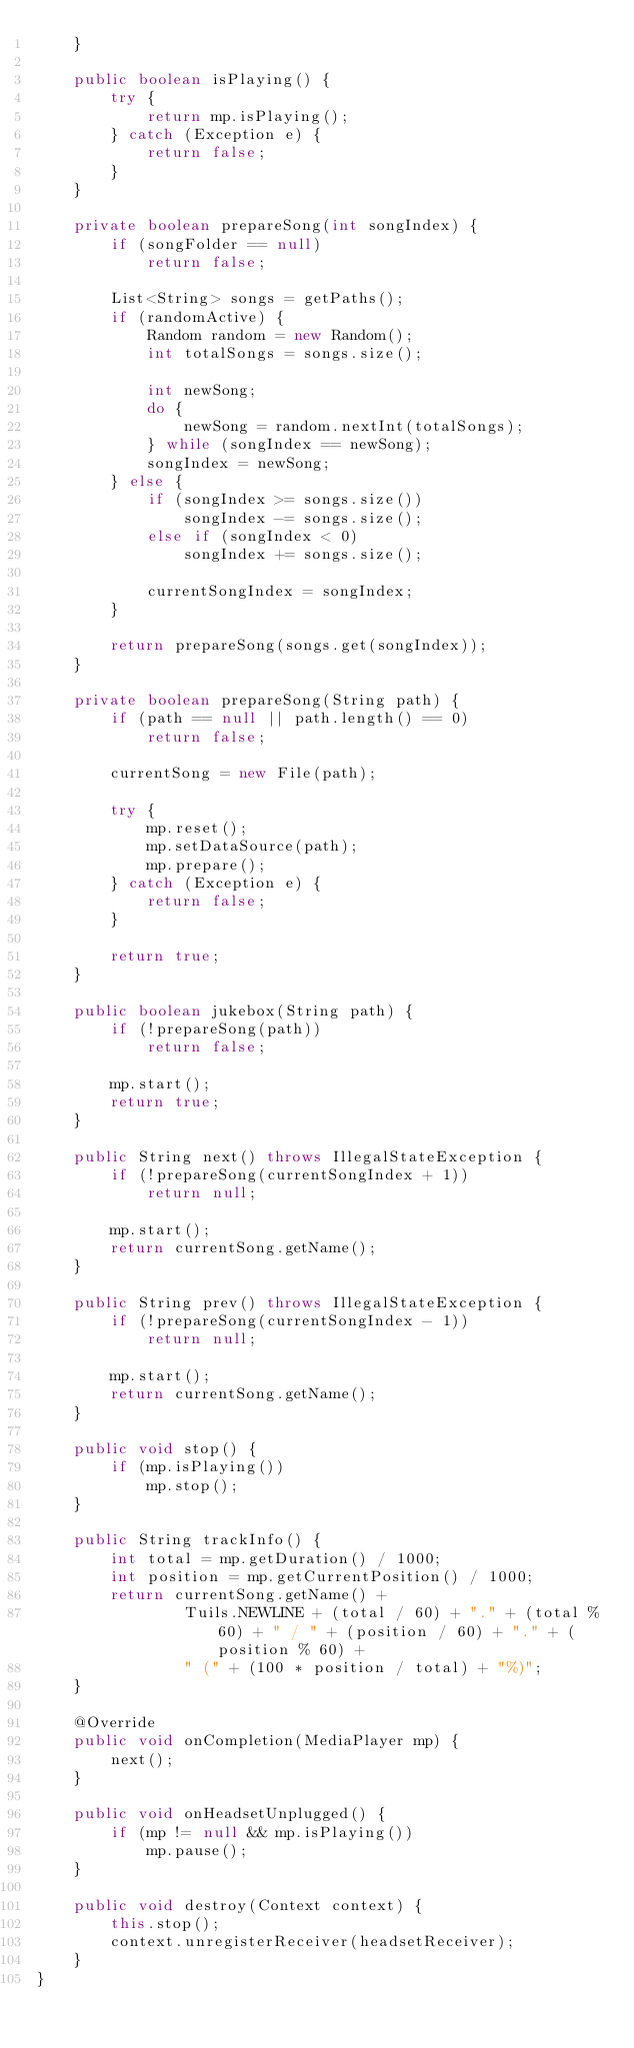<code> <loc_0><loc_0><loc_500><loc_500><_Java_>    }

    public boolean isPlaying() {
        try {
            return mp.isPlaying();
        } catch (Exception e) {
            return false;
        }
    }

    private boolean prepareSong(int songIndex) {
        if (songFolder == null)
            return false;

        List<String> songs = getPaths();
        if (randomActive) {
            Random random = new Random();
            int totalSongs = songs.size();

            int newSong;
            do {
                newSong = random.nextInt(totalSongs);
            } while (songIndex == newSong);
            songIndex = newSong;
        } else {
            if (songIndex >= songs.size())
                songIndex -= songs.size();
            else if (songIndex < 0)
                songIndex += songs.size();

            currentSongIndex = songIndex;
        }

        return prepareSong(songs.get(songIndex));
    }

    private boolean prepareSong(String path) {
        if (path == null || path.length() == 0)
            return false;

        currentSong = new File(path);

        try {
            mp.reset();
            mp.setDataSource(path);
            mp.prepare();
        } catch (Exception e) {
            return false;
        }

        return true;
    }

    public boolean jukebox(String path) {
        if (!prepareSong(path))
            return false;

        mp.start();
        return true;
    }

    public String next() throws IllegalStateException {
        if (!prepareSong(currentSongIndex + 1))
            return null;

        mp.start();
        return currentSong.getName();
    }

    public String prev() throws IllegalStateException {
        if (!prepareSong(currentSongIndex - 1))
            return null;

        mp.start();
        return currentSong.getName();
    }

    public void stop() {
        if (mp.isPlaying())
            mp.stop();
    }

    public String trackInfo() {
        int total = mp.getDuration() / 1000;
        int position = mp.getCurrentPosition() / 1000;
        return currentSong.getName() +
                Tuils.NEWLINE + (total / 60) + "." + (total % 60) + " / " + (position / 60) + "." + (position % 60) +
                " (" + (100 * position / total) + "%)";
    }

    @Override
    public void onCompletion(MediaPlayer mp) {
        next();
    }

    public void onHeadsetUnplugged() {
        if (mp != null && mp.isPlaying())
            mp.pause();
    }

    public void destroy(Context context) {
        this.stop();
        context.unregisterReceiver(headsetReceiver);
    }
}
</code> 